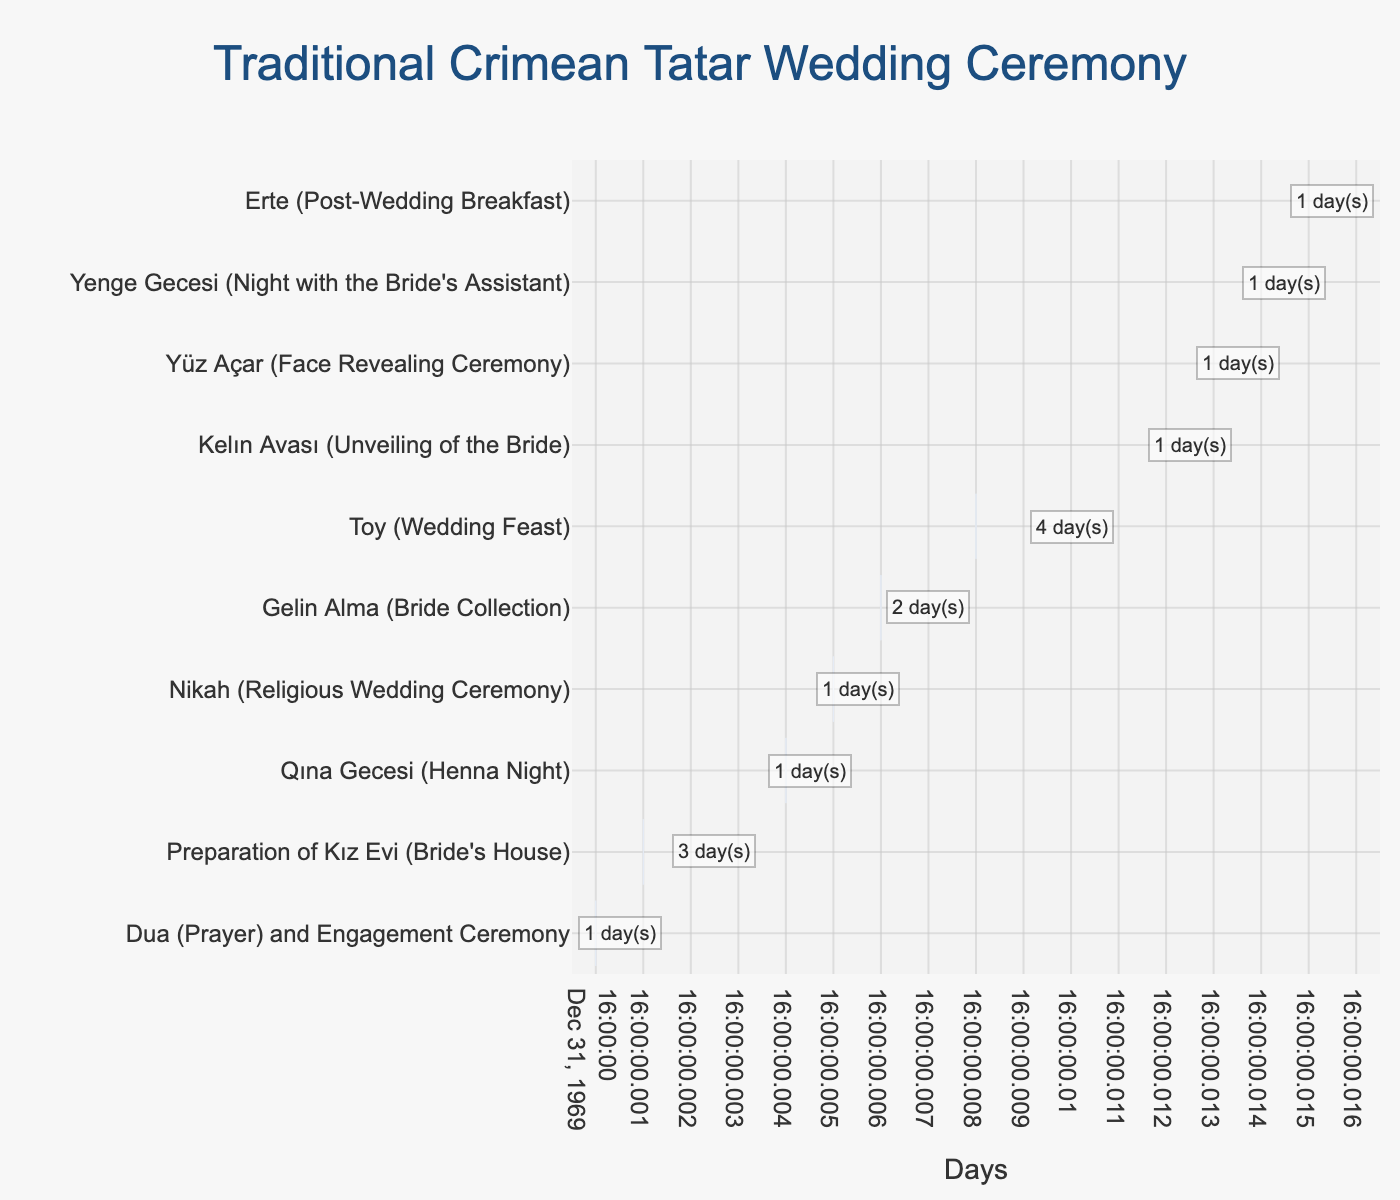What's the title of the figure? The title of the figure is directly shown at the top of the chart.
Answer: "Traditional Crimean Tatar Wedding Ceremony" How many phases are depicted in the chart? Count the number of distinct tasks on the y-axis.
Answer: 10 What’s the duration of the "Toy (Wedding Feast)" phase? Look for the "Toy (Wedding Feast)" task and read off its duration.
Answer: 4 days Which phase starts immediately after "Qına Gecesi (Henna Night)"? Identify the end of "Qına Gecesi (Henna Night)" (Day 5) and see the phase starting at Day 5.
Answer: "Nikah (Religious Wedding Ceremony)" What is the total duration of all phases combined? Sum the durations of all phases: 1 + 3 + 1 + 1 + 2 + 4 + 1 + 1 + 1 + 1.
Answer: 16 days Which phase lasts the longest? Compare the durations of all tasks.
Answer: "Toy (Wedding Feast)" How many phases have a duration of exactly 1 day? Count the tasks with a duration of 1 day. They are "Dua (Prayer) and Engagement Ceremony", "Qına Gecesi (Henna Night)", "Nikah (Religious Wedding Ceremony)", "Kelın Avası (Unveiling of the Bride)", "Yüz Açar (Face Revealing Ceremony)", "Yenge Gecesi (Night with the Bride's Assistant)", and "Erte (Post-Wedding Breakfast)".
Answer: 7 Which phase occurs right before "Kelın Avası (Unveiling of the Bride)"? Identify the start of "Kelın Avası (Unveiling of the Bride)" (Day 12), then look for the phase ending at Day 12.
Answer: "Toy (Wedding Feast)" What is the average duration of each phase? Divide the total duration (16 days) by the number of phases (10).
Answer: 1.6 days What’s the difference in duration between the longest and shortest phases? The longest phase ("Toy (Wedding Feast)") is 4 days and the shortest phase (several 1-day tasks) is 1 day. So, 4 - 1.
Answer: 3 days 